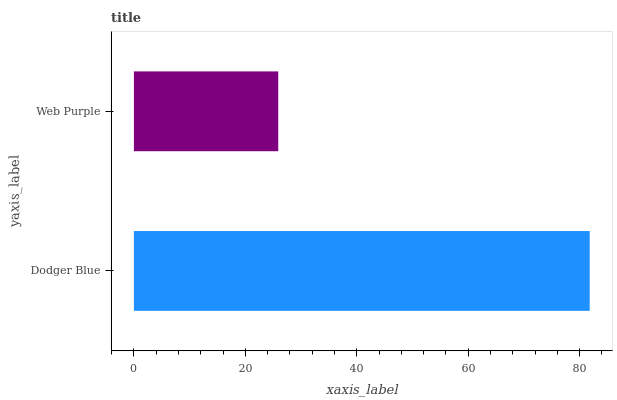Is Web Purple the minimum?
Answer yes or no. Yes. Is Dodger Blue the maximum?
Answer yes or no. Yes. Is Web Purple the maximum?
Answer yes or no. No. Is Dodger Blue greater than Web Purple?
Answer yes or no. Yes. Is Web Purple less than Dodger Blue?
Answer yes or no. Yes. Is Web Purple greater than Dodger Blue?
Answer yes or no. No. Is Dodger Blue less than Web Purple?
Answer yes or no. No. Is Dodger Blue the high median?
Answer yes or no. Yes. Is Web Purple the low median?
Answer yes or no. Yes. Is Web Purple the high median?
Answer yes or no. No. Is Dodger Blue the low median?
Answer yes or no. No. 